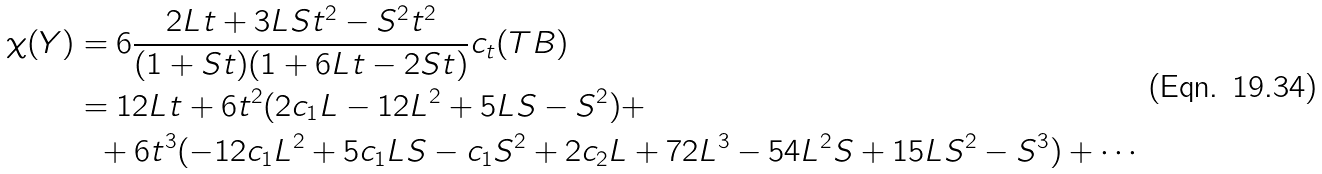Convert formula to latex. <formula><loc_0><loc_0><loc_500><loc_500>\chi ( Y ) & = 6 \frac { 2 L t + 3 L S t ^ { 2 } - S ^ { 2 } t ^ { 2 } } { ( 1 + S t ) ( 1 + 6 L t - 2 S t ) } c _ { t } ( T B ) \\ & = 1 2 L t + 6 t ^ { 2 } ( 2 c _ { 1 } L - 1 2 L ^ { 2 } + 5 L S - S ^ { 2 } ) + \\ & \ \ + 6 t ^ { 3 } ( - 1 2 c _ { 1 } L ^ { 2 } + 5 c _ { 1 } L S - c _ { 1 } S ^ { 2 } + 2 c _ { 2 } L + 7 2 L ^ { 3 } - 5 4 L ^ { 2 } S + 1 5 L S ^ { 2 } - S ^ { 3 } ) + \cdots</formula> 